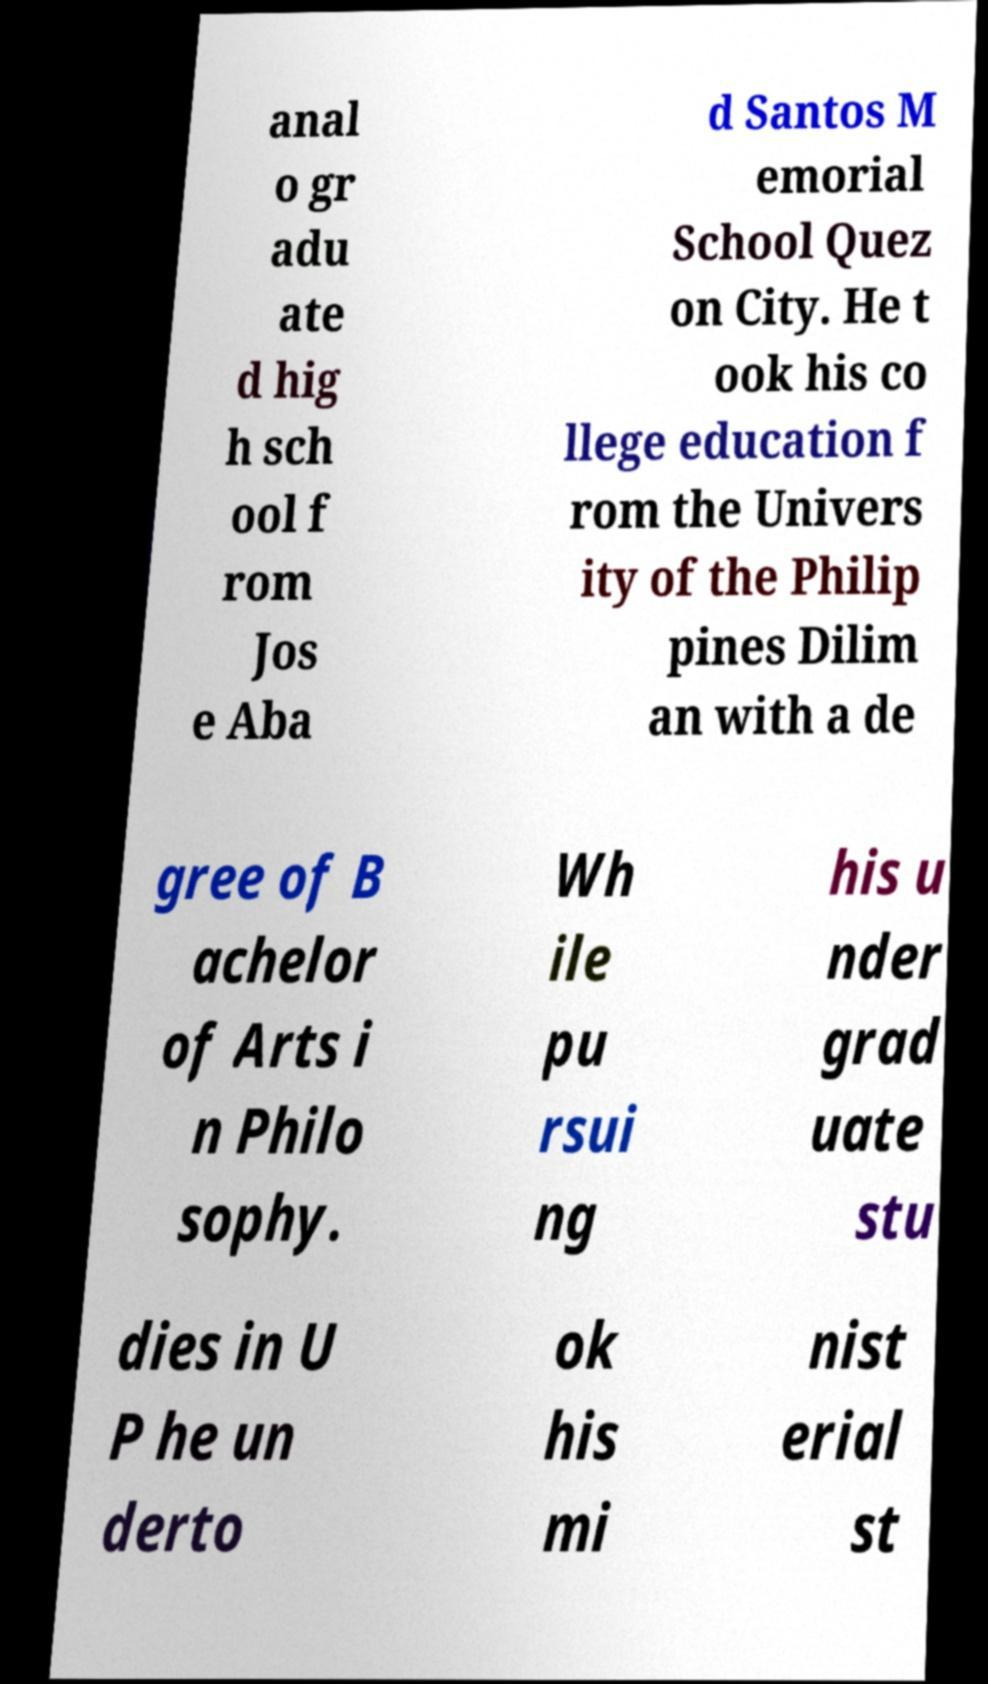Could you assist in decoding the text presented in this image and type it out clearly? anal o gr adu ate d hig h sch ool f rom Jos e Aba d Santos M emorial School Quez on City. He t ook his co llege education f rom the Univers ity of the Philip pines Dilim an with a de gree of B achelor of Arts i n Philo sophy. Wh ile pu rsui ng his u nder grad uate stu dies in U P he un derto ok his mi nist erial st 